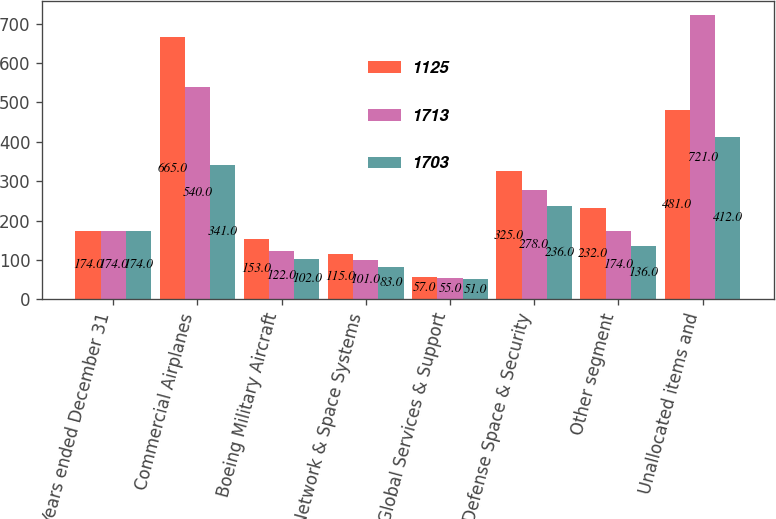Convert chart. <chart><loc_0><loc_0><loc_500><loc_500><stacked_bar_chart><ecel><fcel>Years ended December 31<fcel>Commercial Airplanes<fcel>Boeing Military Aircraft<fcel>Network & Space Systems<fcel>Global Services & Support<fcel>Total Defense Space & Security<fcel>Other segment<fcel>Unallocated items and<nl><fcel>1125<fcel>174<fcel>665<fcel>153<fcel>115<fcel>57<fcel>325<fcel>232<fcel>481<nl><fcel>1713<fcel>174<fcel>540<fcel>122<fcel>101<fcel>55<fcel>278<fcel>174<fcel>721<nl><fcel>1703<fcel>174<fcel>341<fcel>102<fcel>83<fcel>51<fcel>236<fcel>136<fcel>412<nl></chart> 